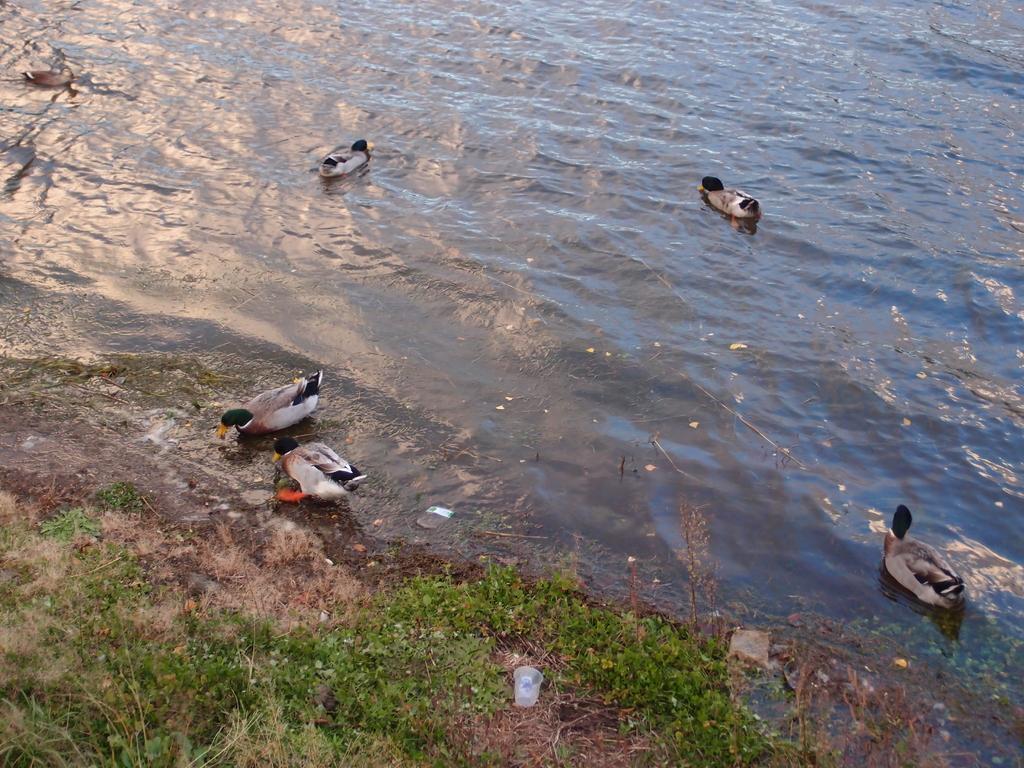Please provide a concise description of this image. In this picture we can see many birds on the water. On the bottom we can see a plastic glass near to the grass. Here we can see bird, who is drinking. 